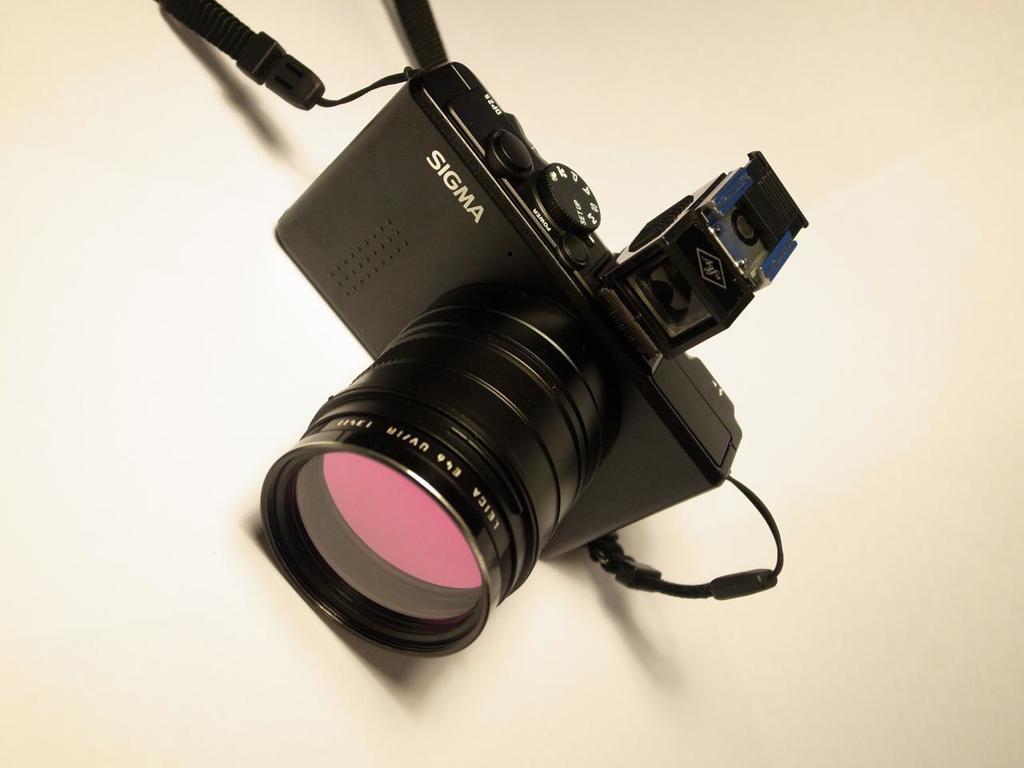Can you describe this image briefly? Here we can see a camera on a platform. 